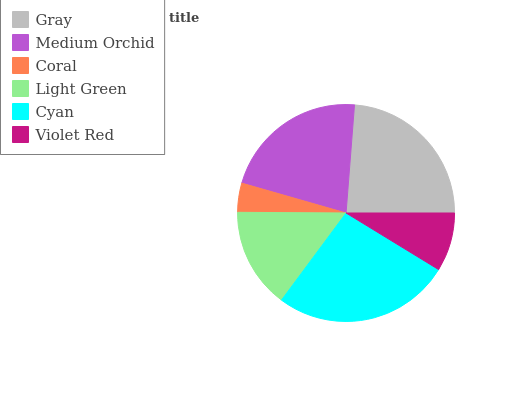Is Coral the minimum?
Answer yes or no. Yes. Is Cyan the maximum?
Answer yes or no. Yes. Is Medium Orchid the minimum?
Answer yes or no. No. Is Medium Orchid the maximum?
Answer yes or no. No. Is Gray greater than Medium Orchid?
Answer yes or no. Yes. Is Medium Orchid less than Gray?
Answer yes or no. Yes. Is Medium Orchid greater than Gray?
Answer yes or no. No. Is Gray less than Medium Orchid?
Answer yes or no. No. Is Medium Orchid the high median?
Answer yes or no. Yes. Is Light Green the low median?
Answer yes or no. Yes. Is Violet Red the high median?
Answer yes or no. No. Is Cyan the low median?
Answer yes or no. No. 